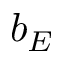Convert formula to latex. <formula><loc_0><loc_0><loc_500><loc_500>b _ { E }</formula> 